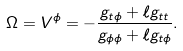Convert formula to latex. <formula><loc_0><loc_0><loc_500><loc_500>\Omega = V ^ { \phi } = - \frac { g _ { t \phi } + \ell g _ { t t } } { g _ { \phi \phi } + \ell g _ { t \phi } } .</formula> 